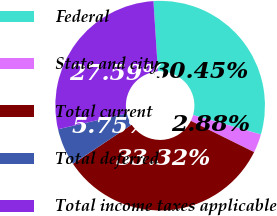Convert chart. <chart><loc_0><loc_0><loc_500><loc_500><pie_chart><fcel>Federal<fcel>State and city<fcel>Total current<fcel>Total deferred<fcel>Total income taxes applicable<nl><fcel>30.45%<fcel>2.88%<fcel>33.32%<fcel>5.75%<fcel>27.59%<nl></chart> 